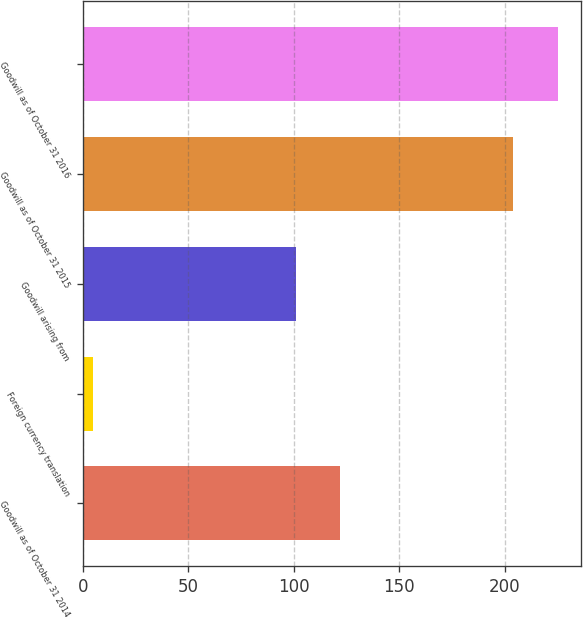Convert chart. <chart><loc_0><loc_0><loc_500><loc_500><bar_chart><fcel>Goodwill as of October 31 2014<fcel>Foreign currency translation<fcel>Goodwill arising from<fcel>Goodwill as of October 31 2015<fcel>Goodwill as of October 31 2016<nl><fcel>122.1<fcel>5<fcel>101<fcel>204<fcel>225.1<nl></chart> 